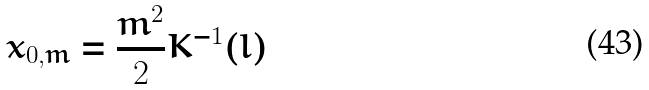Convert formula to latex. <formula><loc_0><loc_0><loc_500><loc_500>x _ { 0 , m } = \frac { m ^ { 2 } } { 2 } K ^ { - 1 } ( l )</formula> 